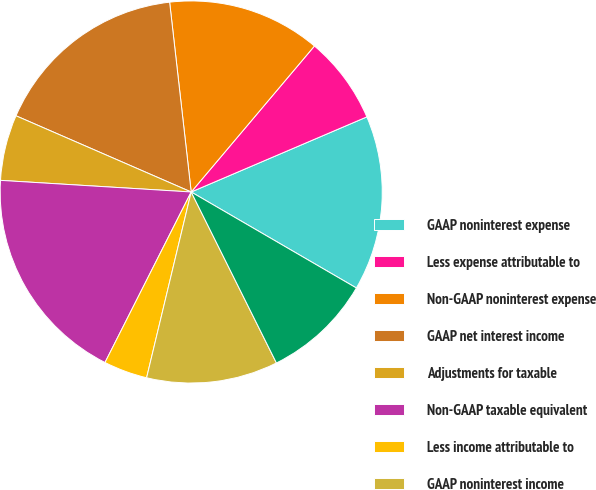<chart> <loc_0><loc_0><loc_500><loc_500><pie_chart><fcel>GAAP noninterest expense<fcel>Less expense attributable to<fcel>Non-GAAP noninterest expense<fcel>GAAP net interest income<fcel>Adjustments for taxable<fcel>Non-GAAP taxable equivalent<fcel>Less income attributable to<fcel>GAAP noninterest income<fcel>Non-GAAP noninterest income<nl><fcel>14.81%<fcel>7.41%<fcel>12.96%<fcel>16.67%<fcel>5.56%<fcel>18.52%<fcel>3.7%<fcel>11.11%<fcel>9.26%<nl></chart> 